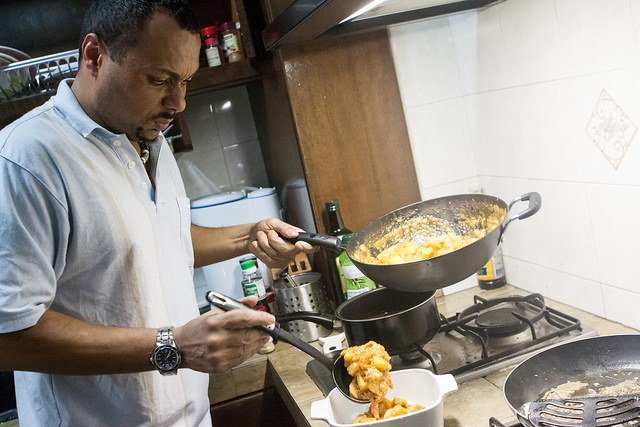Describe the objects in this image and their specific colors. I can see people in black, lightgray, darkgray, and gray tones, oven in black, gray, lightgray, and darkgray tones, bowl in black, lightgray, tan, and darkgray tones, spoon in black, gray, lightgray, and darkgray tones, and bottle in black, lightgray, gray, and olive tones in this image. 